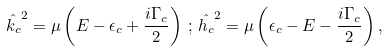<formula> <loc_0><loc_0><loc_500><loc_500>\hat { k _ { c } } ^ { 2 } = \mu \left ( E - \epsilon _ { c } + \frac { i \Gamma _ { c } } { 2 } \right ) \, ; \, \hat { h _ { c } } ^ { 2 } = \mu \left ( \epsilon _ { c } - E - \frac { i \Gamma _ { c } } { 2 } \right ) ,</formula> 